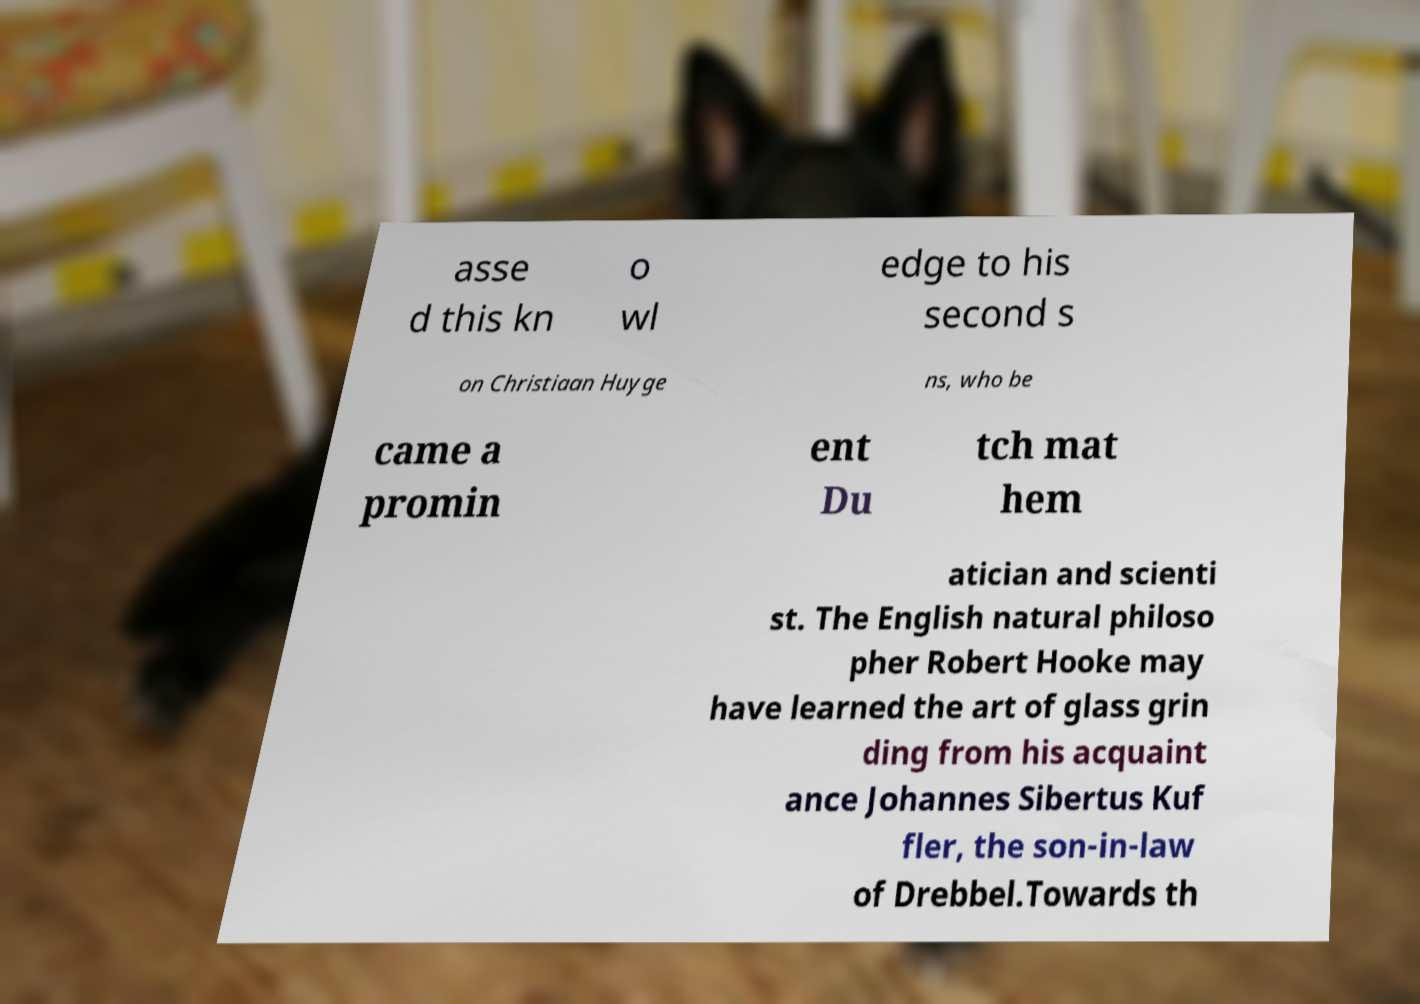Please identify and transcribe the text found in this image. asse d this kn o wl edge to his second s on Christiaan Huyge ns, who be came a promin ent Du tch mat hem atician and scienti st. The English natural philoso pher Robert Hooke may have learned the art of glass grin ding from his acquaint ance Johannes Sibertus Kuf fler, the son-in-law of Drebbel.Towards th 